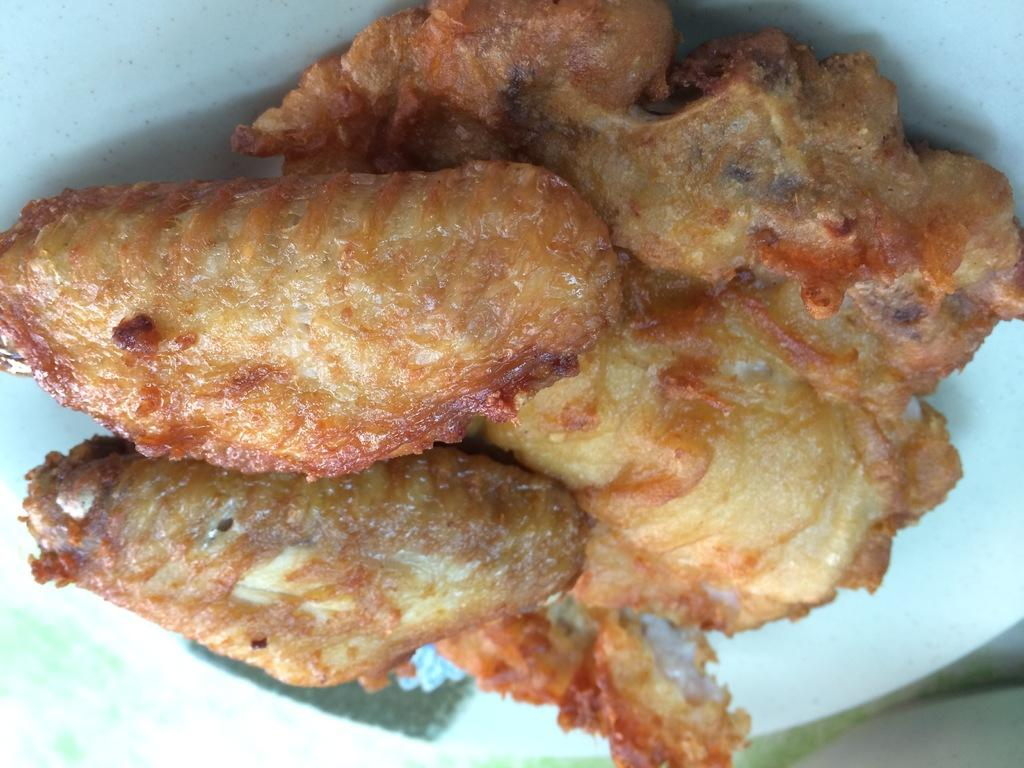What is the color of the plate in the image? The plate in the image is white. What is on the plate? The plate is filled with food items. Who is the creator of the downtown area in the image? There is no downtown area present in the image; it only features a white plate filled with food items. 